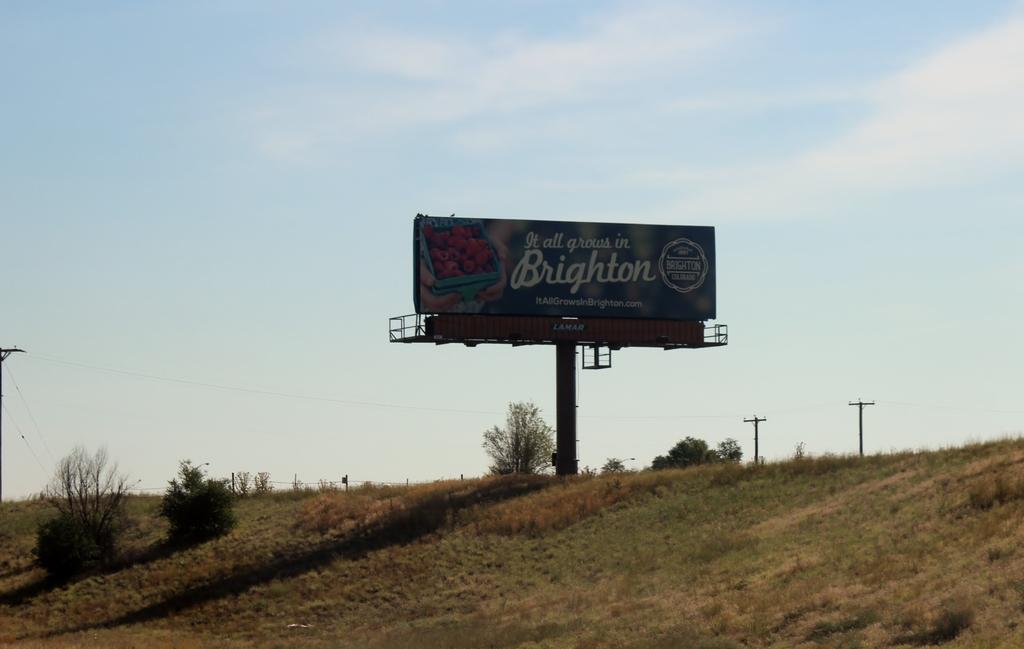In one or two sentences, can you explain what this image depicts? In the foreground of this image, there is grass and few plants on the slope. In the background, there is a hoarding, few poles, trees, sky and the cloud. 